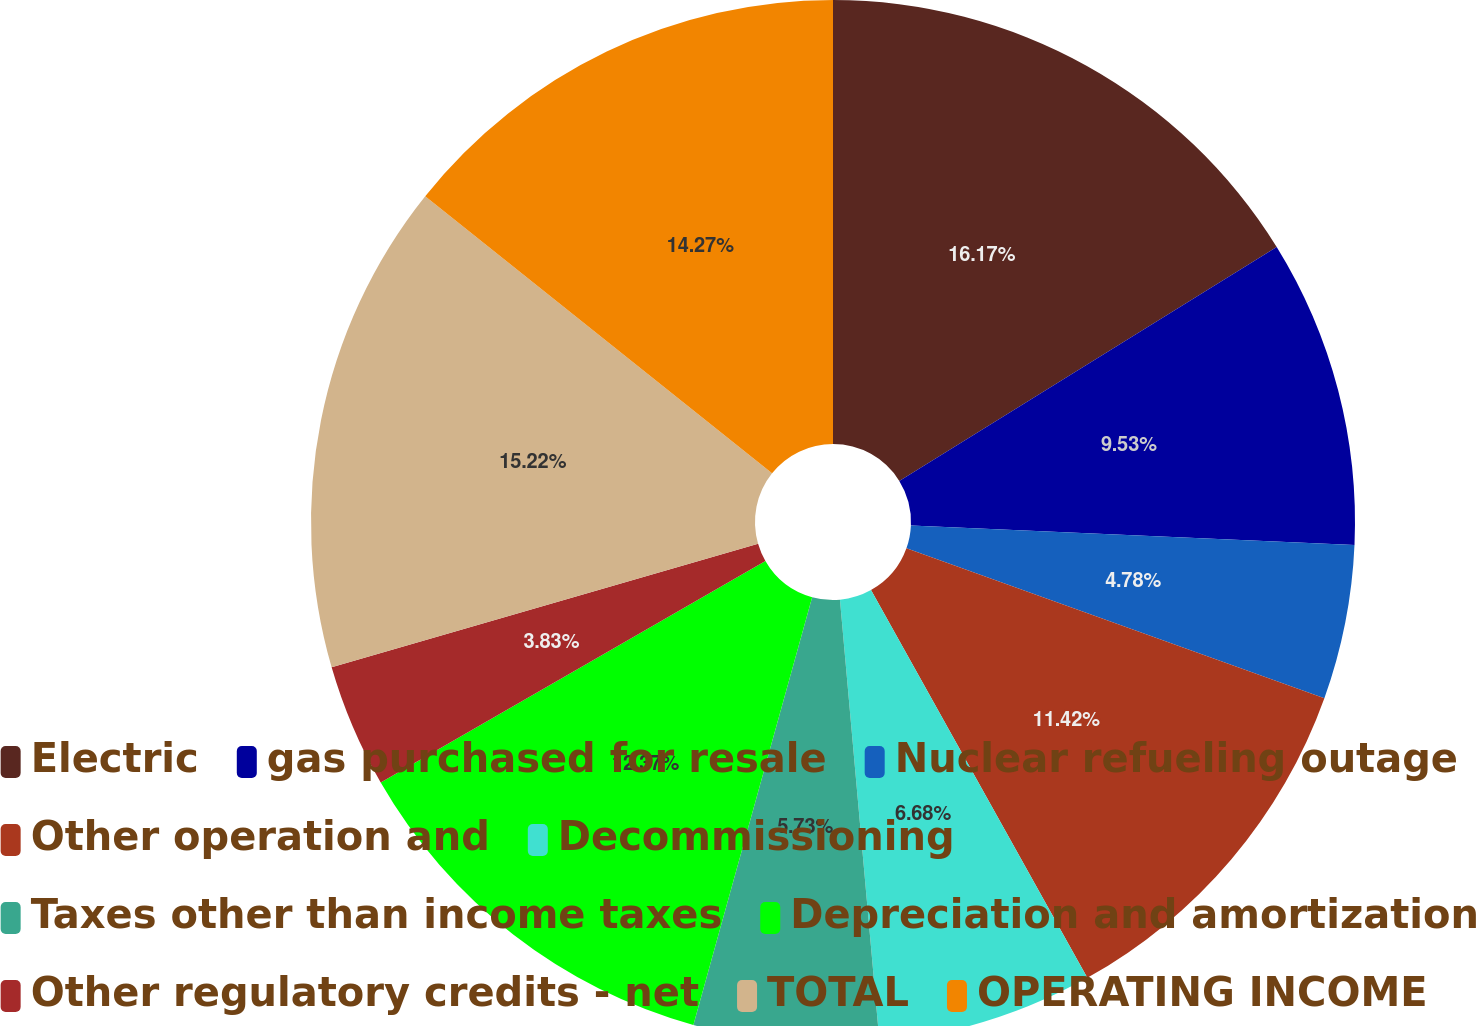<chart> <loc_0><loc_0><loc_500><loc_500><pie_chart><fcel>Electric<fcel>gas purchased for resale<fcel>Nuclear refueling outage<fcel>Other operation and<fcel>Decommissioning<fcel>Taxes other than income taxes<fcel>Depreciation and amortization<fcel>Other regulatory credits - net<fcel>TOTAL<fcel>OPERATING INCOME<nl><fcel>16.17%<fcel>9.53%<fcel>4.78%<fcel>11.42%<fcel>6.68%<fcel>5.73%<fcel>12.37%<fcel>3.83%<fcel>15.22%<fcel>14.27%<nl></chart> 